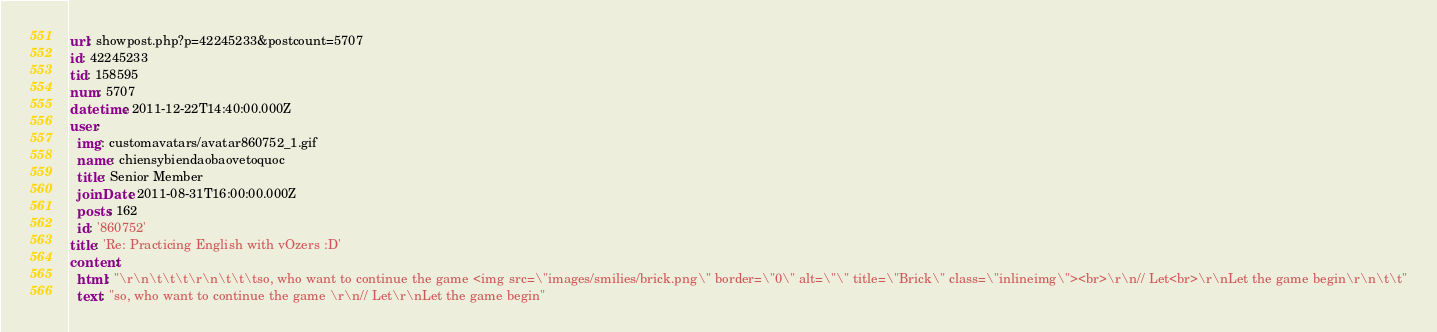<code> <loc_0><loc_0><loc_500><loc_500><_YAML_>url: showpost.php?p=42245233&postcount=5707
id: 42245233
tid: 158595
num: 5707
datetime: 2011-12-22T14:40:00.000Z
user:
  img: customavatars/avatar860752_1.gif
  name: chiensybiendaobaovetoquoc
  title: Senior Member
  joinDate: 2011-08-31T16:00:00.000Z
  posts: 162
  id: '860752'
title: 'Re: Practicing English with vOzers :D'
content:
  html: "\r\n\t\t\t\r\n\t\t\tso, who want to continue the game <img src=\"images/smilies/brick.png\" border=\"0\" alt=\"\" title=\"Brick\" class=\"inlineimg\"><br>\r\n// Let<br>\r\nLet the game begin\r\n\t\t"
  text: "so, who want to continue the game \r\n// Let\r\nLet the game begin"
</code> 